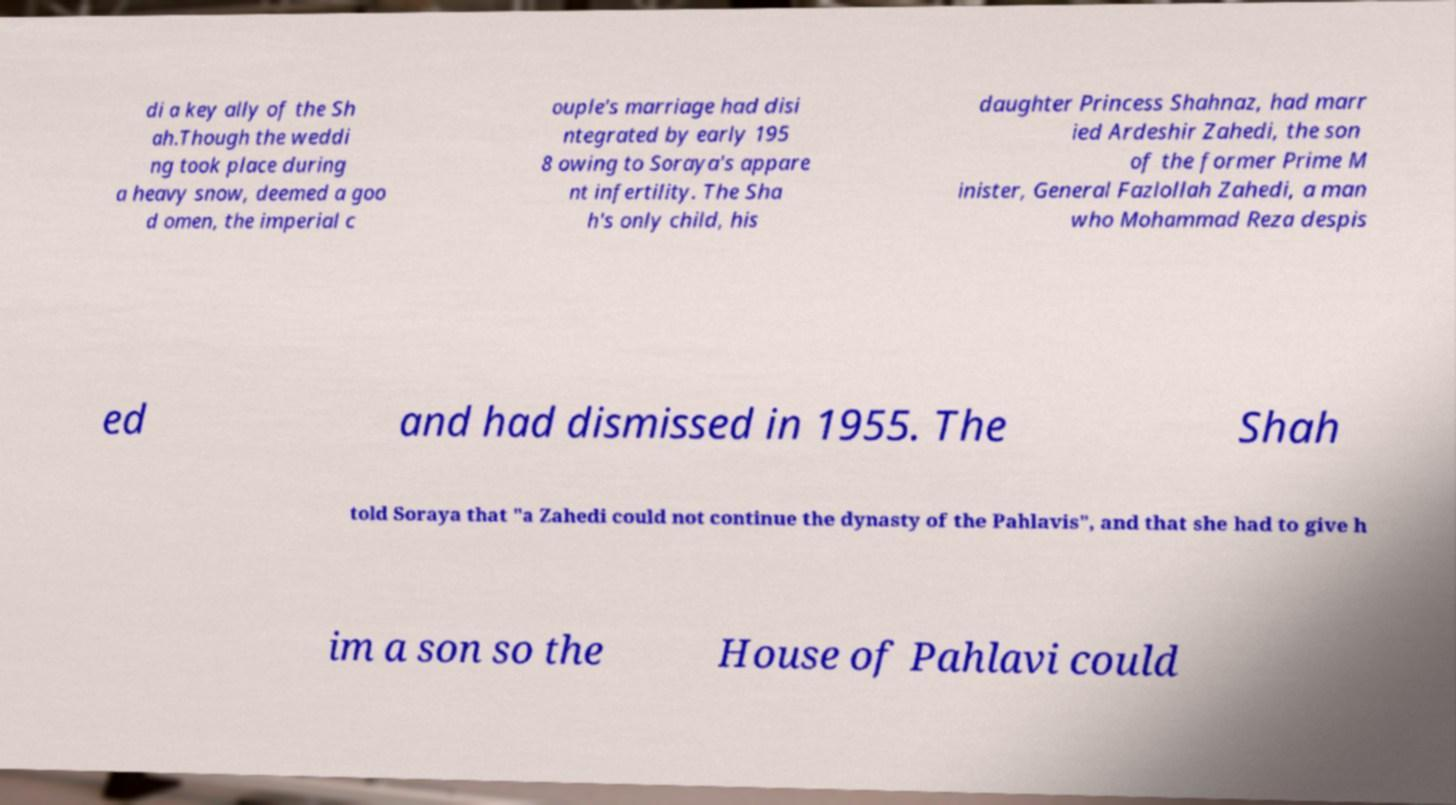Please read and relay the text visible in this image. What does it say? di a key ally of the Sh ah.Though the weddi ng took place during a heavy snow, deemed a goo d omen, the imperial c ouple's marriage had disi ntegrated by early 195 8 owing to Soraya's appare nt infertility. The Sha h's only child, his daughter Princess Shahnaz, had marr ied Ardeshir Zahedi, the son of the former Prime M inister, General Fazlollah Zahedi, a man who Mohammad Reza despis ed and had dismissed in 1955. The Shah told Soraya that "a Zahedi could not continue the dynasty of the Pahlavis", and that she had to give h im a son so the House of Pahlavi could 